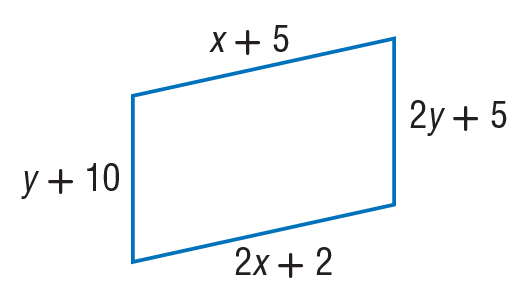Question: Find x so that the quadrilateral is a parallelogram.
Choices:
A. 3
B. 5
C. 7
D. 8
Answer with the letter. Answer: A Question: Find y so that the quadrilateral is a parallelogram.
Choices:
A. 5
B. 10
C. 12
D. 50
Answer with the letter. Answer: A 